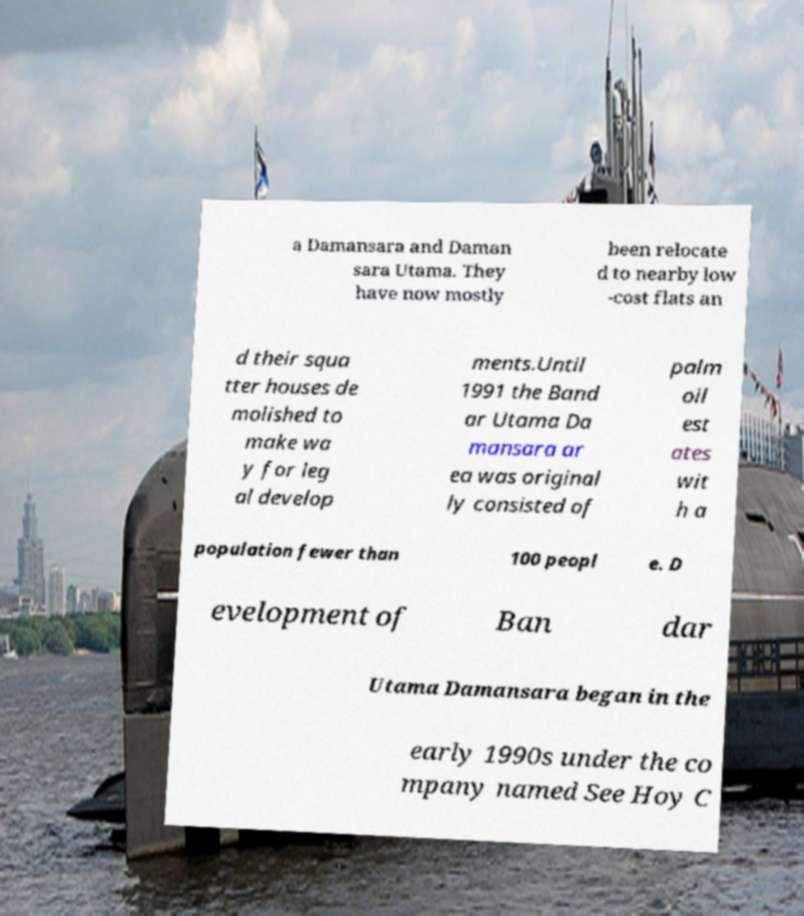Can you read and provide the text displayed in the image?This photo seems to have some interesting text. Can you extract and type it out for me? a Damansara and Daman sara Utama. They have now mostly been relocate d to nearby low -cost flats an d their squa tter houses de molished to make wa y for leg al develop ments.Until 1991 the Band ar Utama Da mansara ar ea was original ly consisted of palm oil est ates wit h a population fewer than 100 peopl e. D evelopment of Ban dar Utama Damansara began in the early 1990s under the co mpany named See Hoy C 